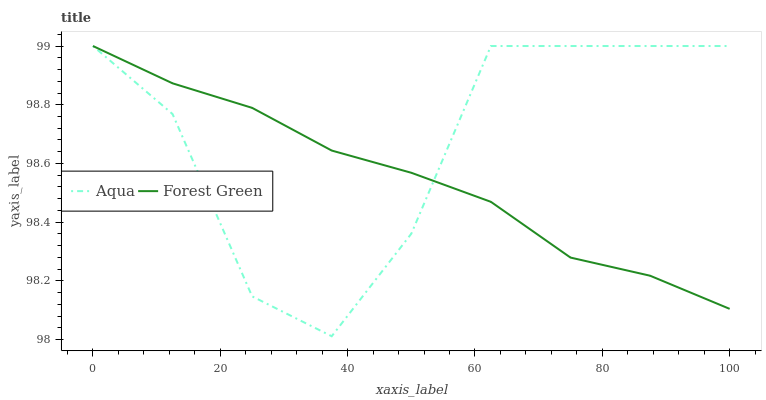Does Forest Green have the minimum area under the curve?
Answer yes or no. Yes. Does Aqua have the maximum area under the curve?
Answer yes or no. Yes. Does Aqua have the minimum area under the curve?
Answer yes or no. No. Is Forest Green the smoothest?
Answer yes or no. Yes. Is Aqua the roughest?
Answer yes or no. Yes. Is Aqua the smoothest?
Answer yes or no. No. 